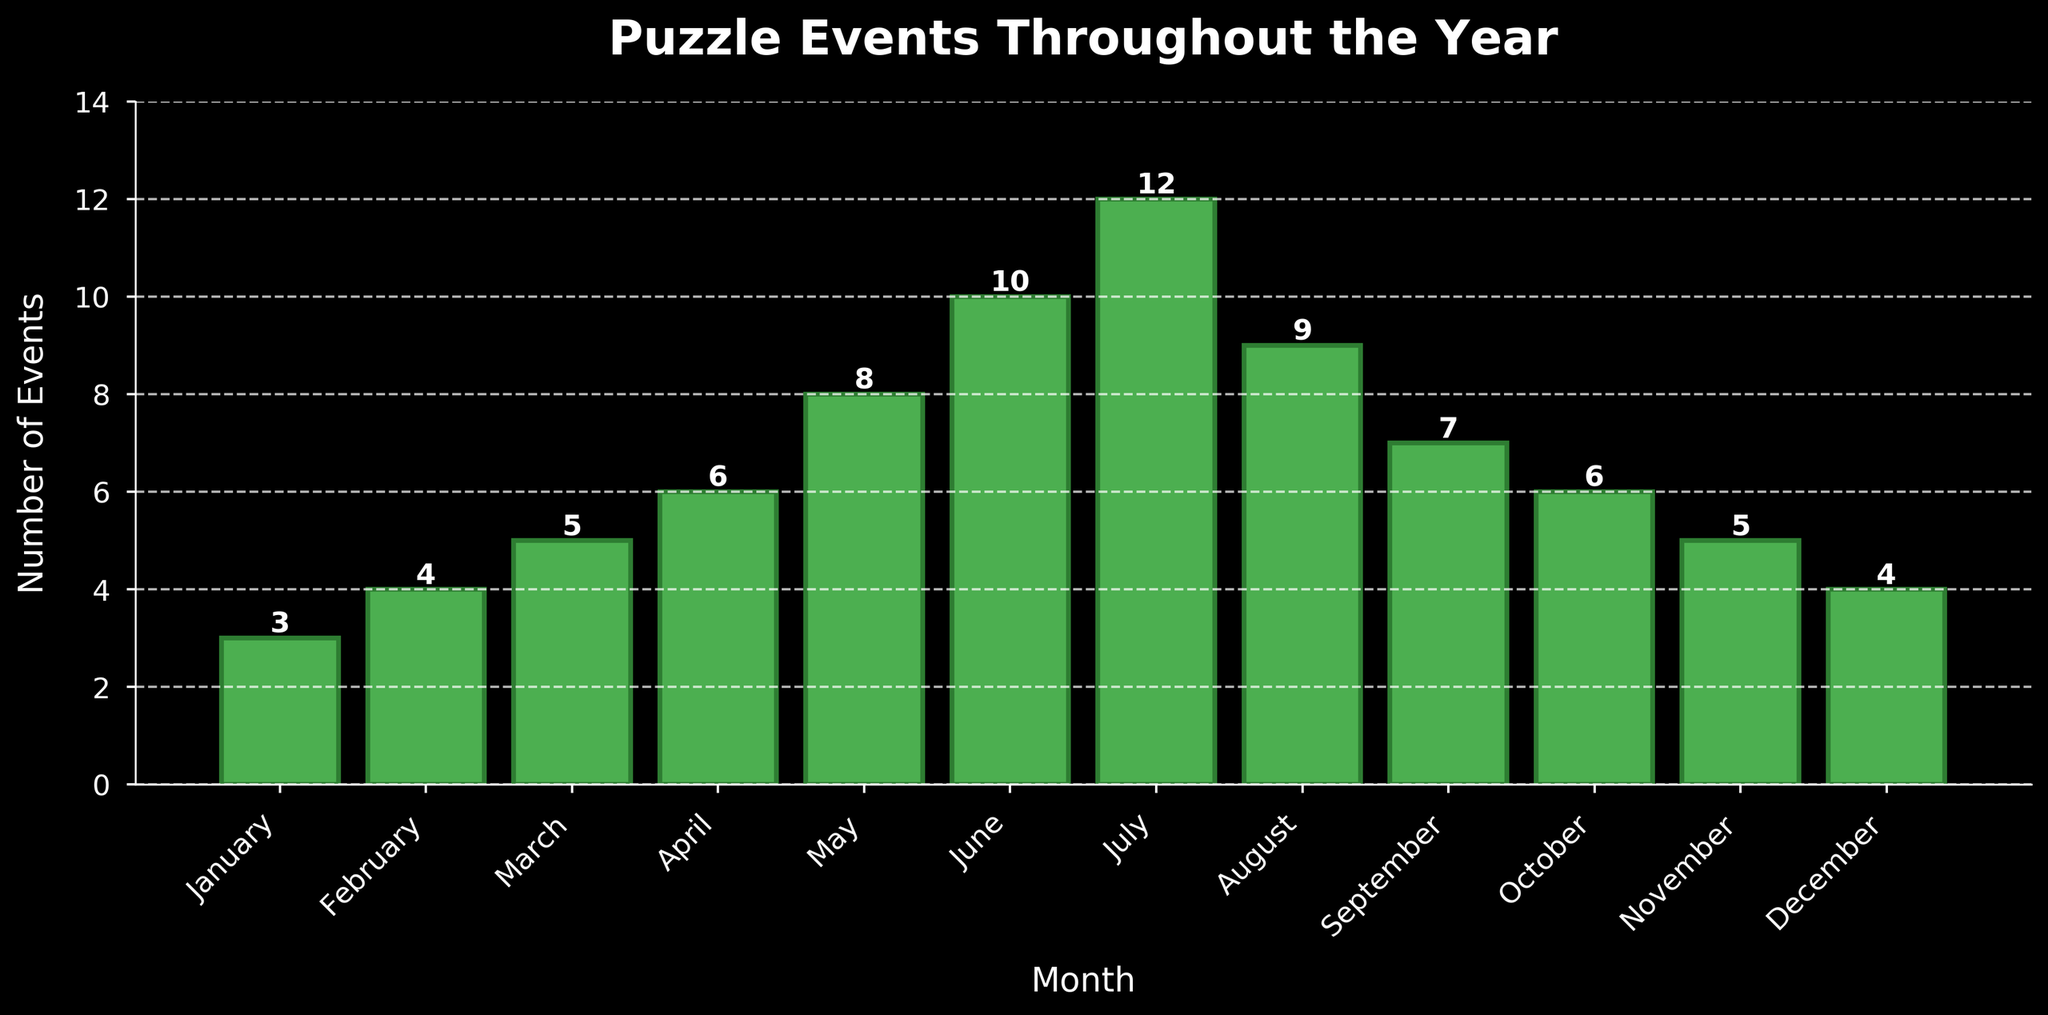What is the total number of puzzle events organized in the first quarter (January to March)? First, identify the number of events for January (3), February (4), and March (5). Sum these values: 3 + 4 + 5 = 12.
Answer: 12 Which month had the highest number of puzzle events? Look at the heights of the bars and find the tallest one, which corresponds to July with 12 events.
Answer: July How many more puzzle events were organized in June compared to December? Identify the values for June (10) and December (4). Subtract the number of events in December from those in June: 10 - 4 = 6.
Answer: 6 What is the average number of puzzle events organized per month throughout the year? Sum the number of events for all months (3+4+5+6+8+10+12+9+7+6+5+4 = 79) and divide by 12 (number of months): 79 / 12 ≈ 6.58.
Answer: 6.58 How does the number of events in August compare to the number of events in September? Identify the values for August (9) and September (7). August has 2 more events than September.
Answer: August had 2 more In which month(s) did the number of puzzle events equal the median number of events for the year? Arrange the number of events in ascending order: 3, 4, 4, 5, 5, 6, 6, 7, 8, 9, 10, 12. The median number of events is the average of the 6th and 7th values: (6 + 6) / 2 = 6. The months are April and October with 6 events each.
Answer: April and October Between which two consecutive months was the biggest increase in the number of puzzle events observed? Calculate the differences between consecutive months: Feb-Jan (4-3=1), Mar-Feb (5-4=1), Apr-Mar (6-5=1), May-Apr (8-6=2), Jun-May (10-8=2), Jul-Jun (12-10=2), Aug-Jul (9-12=-3), Sep-Aug (7-9=-2), Oct-Sep (6-7=-1), Nov-Oct (5-6=-1), Dec-Nov (4-5=-1). The biggest increase (difference of 2) occurred between May and June, June and July.
Answer: May to June and June to July Which months had fewer puzzle events than the yearly average? Calculate the average number of events (79 / 12 ≈ 6.58). The months with fewer events than 6.58 are January (3), February (4), March (5), November (5), and December (4).
Answer: January, February, March, November, and December What was the total number of puzzle events organized in the last quarter of the year (October to December)? Add the number of events for October (6), November (5), and December (4): 6 + 5 + 4 = 15.
Answer: 15 Was there any month with twice as many puzzle events as another month? If so, which pairs of months? Examine each pair of months to find any instance where the number of events in one month is double that in another. June had 10 events, which is twice February's 5, and July had 12 events, which is twice January's 6.
Answer: June and February, July and January 